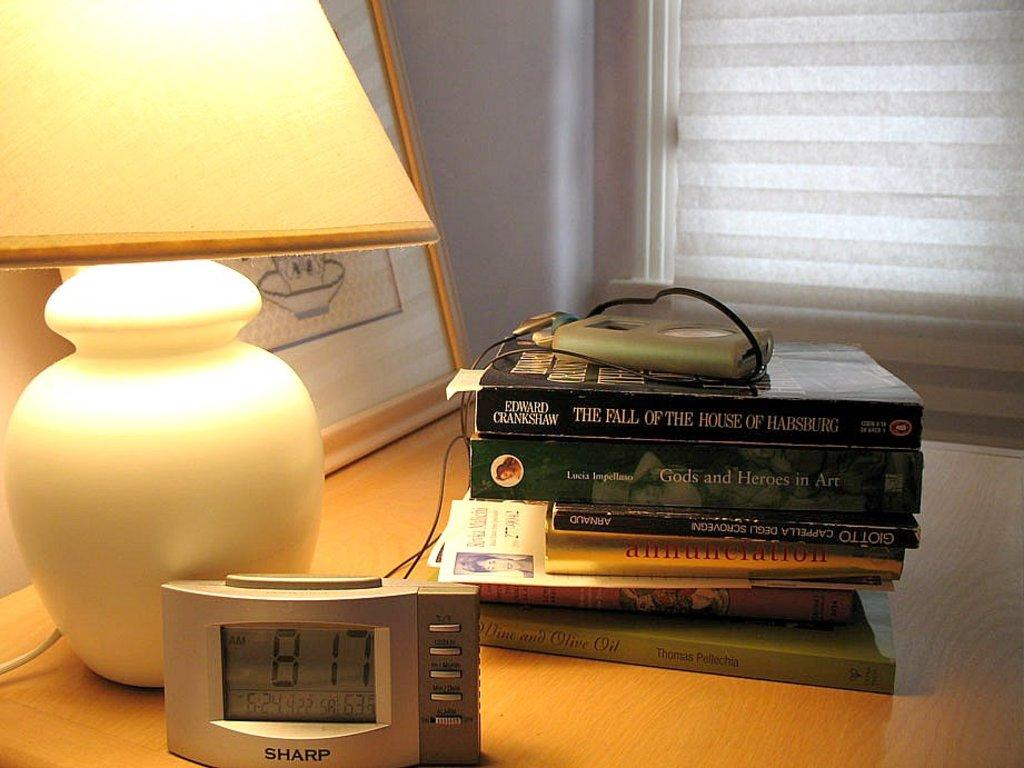Provide a one-sentence caption for the provided image. A Sharp brand clock sits on a bedside table reading 8:17 Am. 